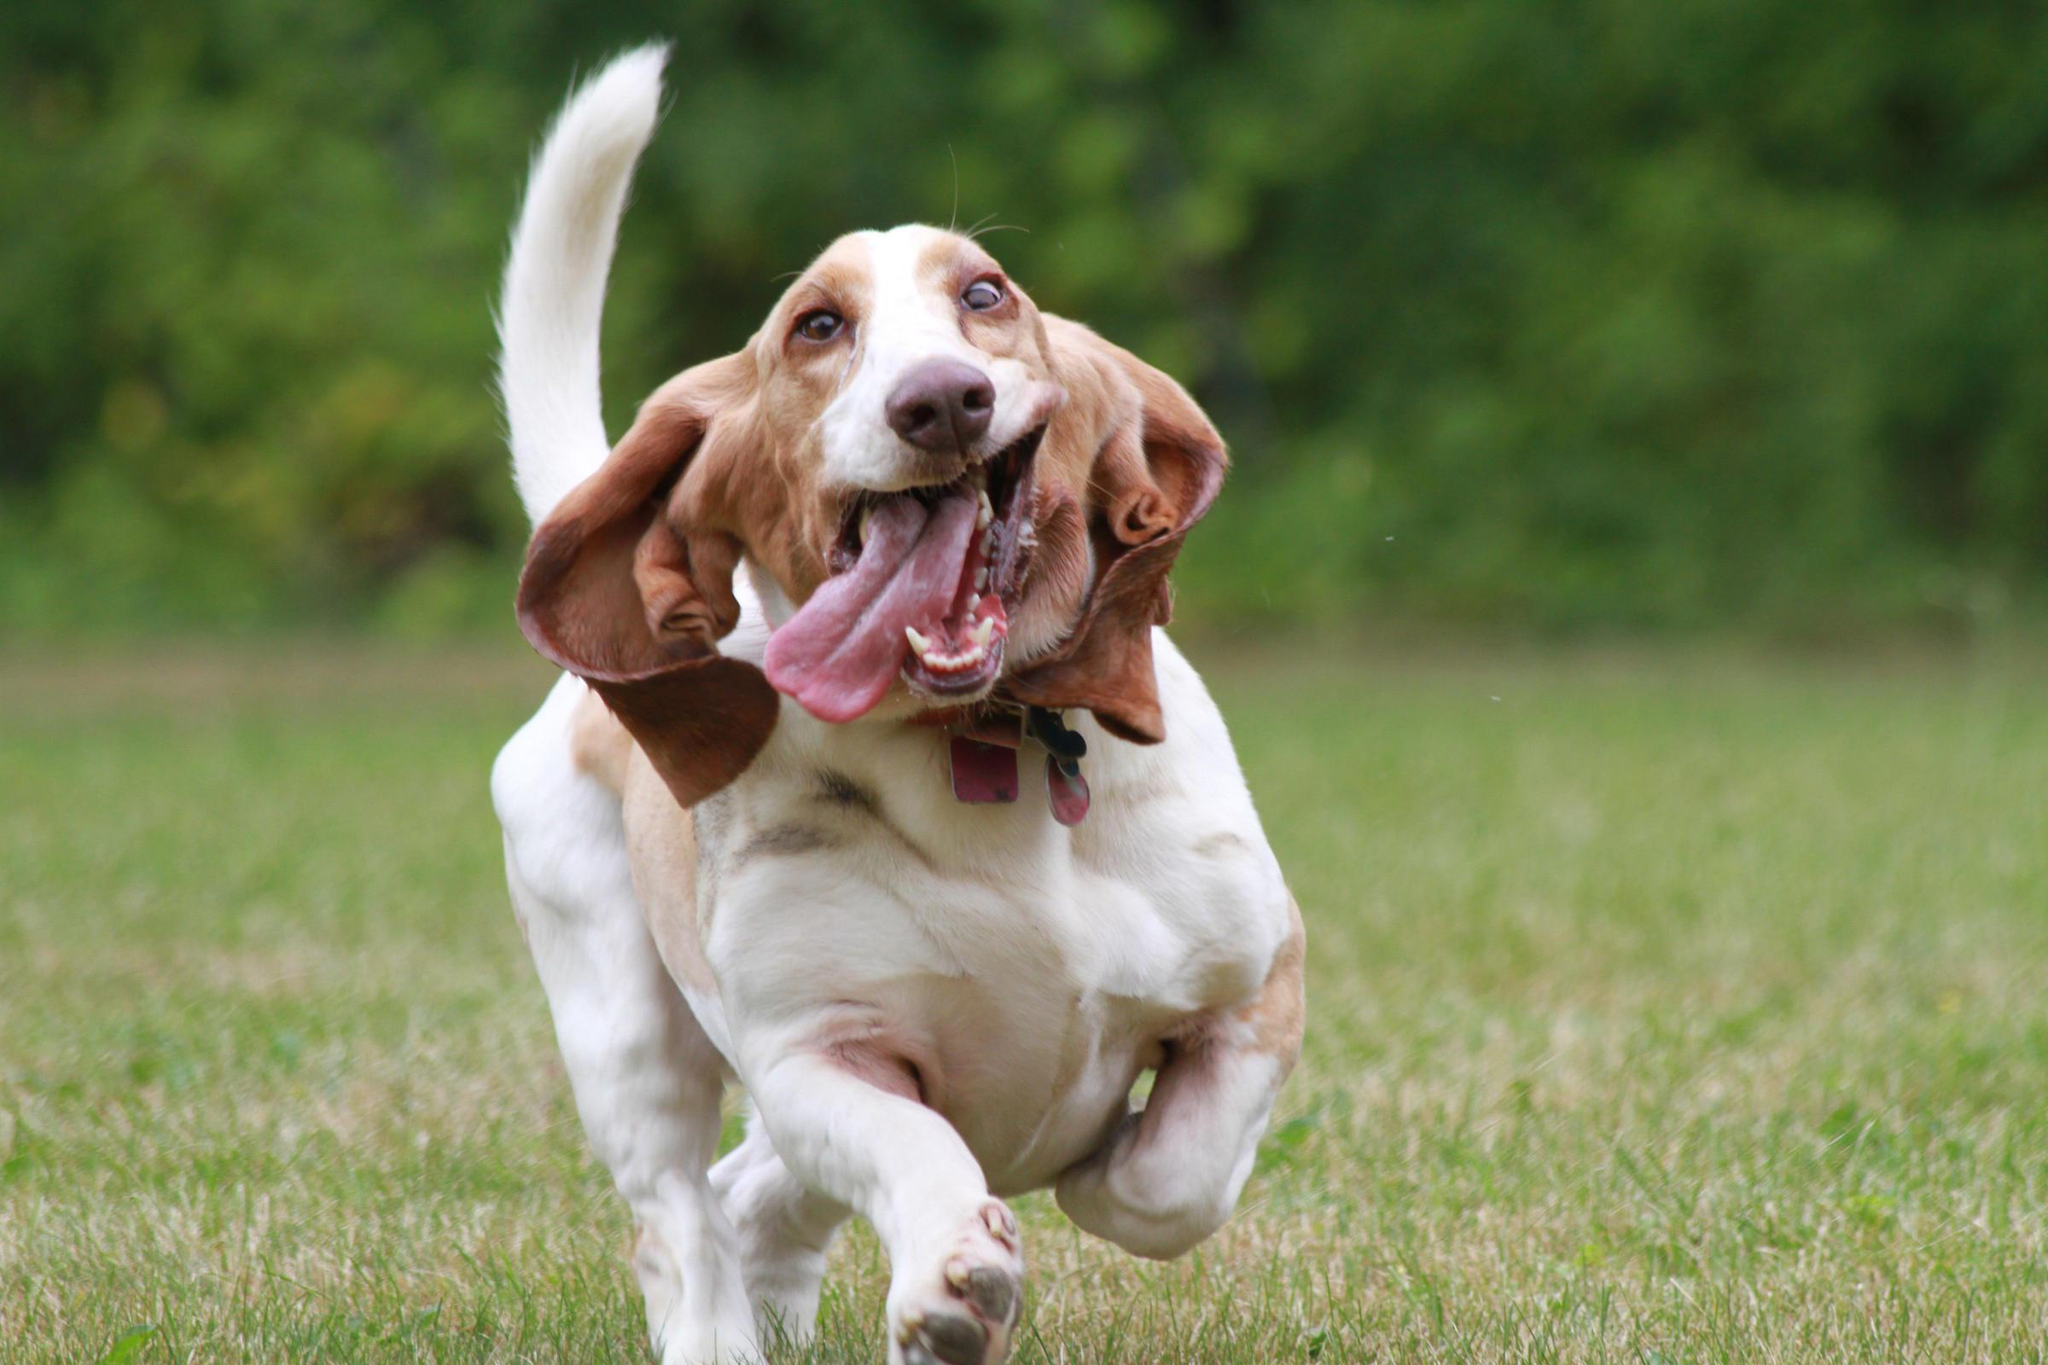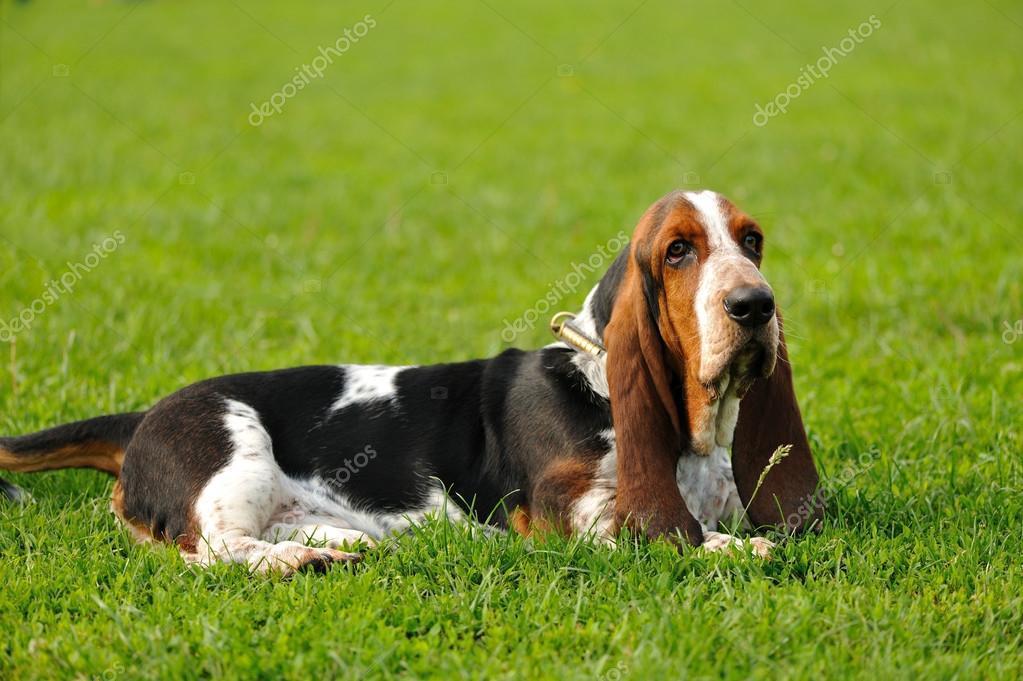The first image is the image on the left, the second image is the image on the right. Given the left and right images, does the statement "A dogs tongue is sticking way out." hold true? Answer yes or no. Yes. The first image is the image on the left, the second image is the image on the right. Evaluate the accuracy of this statement regarding the images: "A basset hound is showing its tongue in exactly one of the photos.". Is it true? Answer yes or no. Yes. 